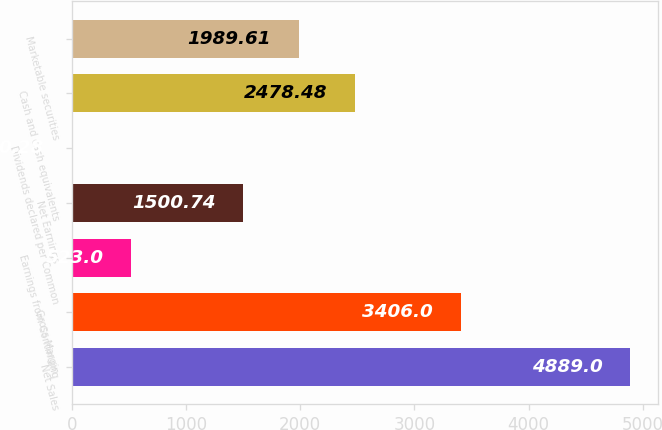Convert chart to OTSL. <chart><loc_0><loc_0><loc_500><loc_500><bar_chart><fcel>Net Sales<fcel>Gross Margin<fcel>Earnings from Continuing<fcel>Net Earnings<fcel>Dividends declared per Common<fcel>Cash and cash equivalents<fcel>Marketable securities<nl><fcel>4889<fcel>3406<fcel>523<fcel>1500.74<fcel>0.28<fcel>2478.48<fcel>1989.61<nl></chart> 